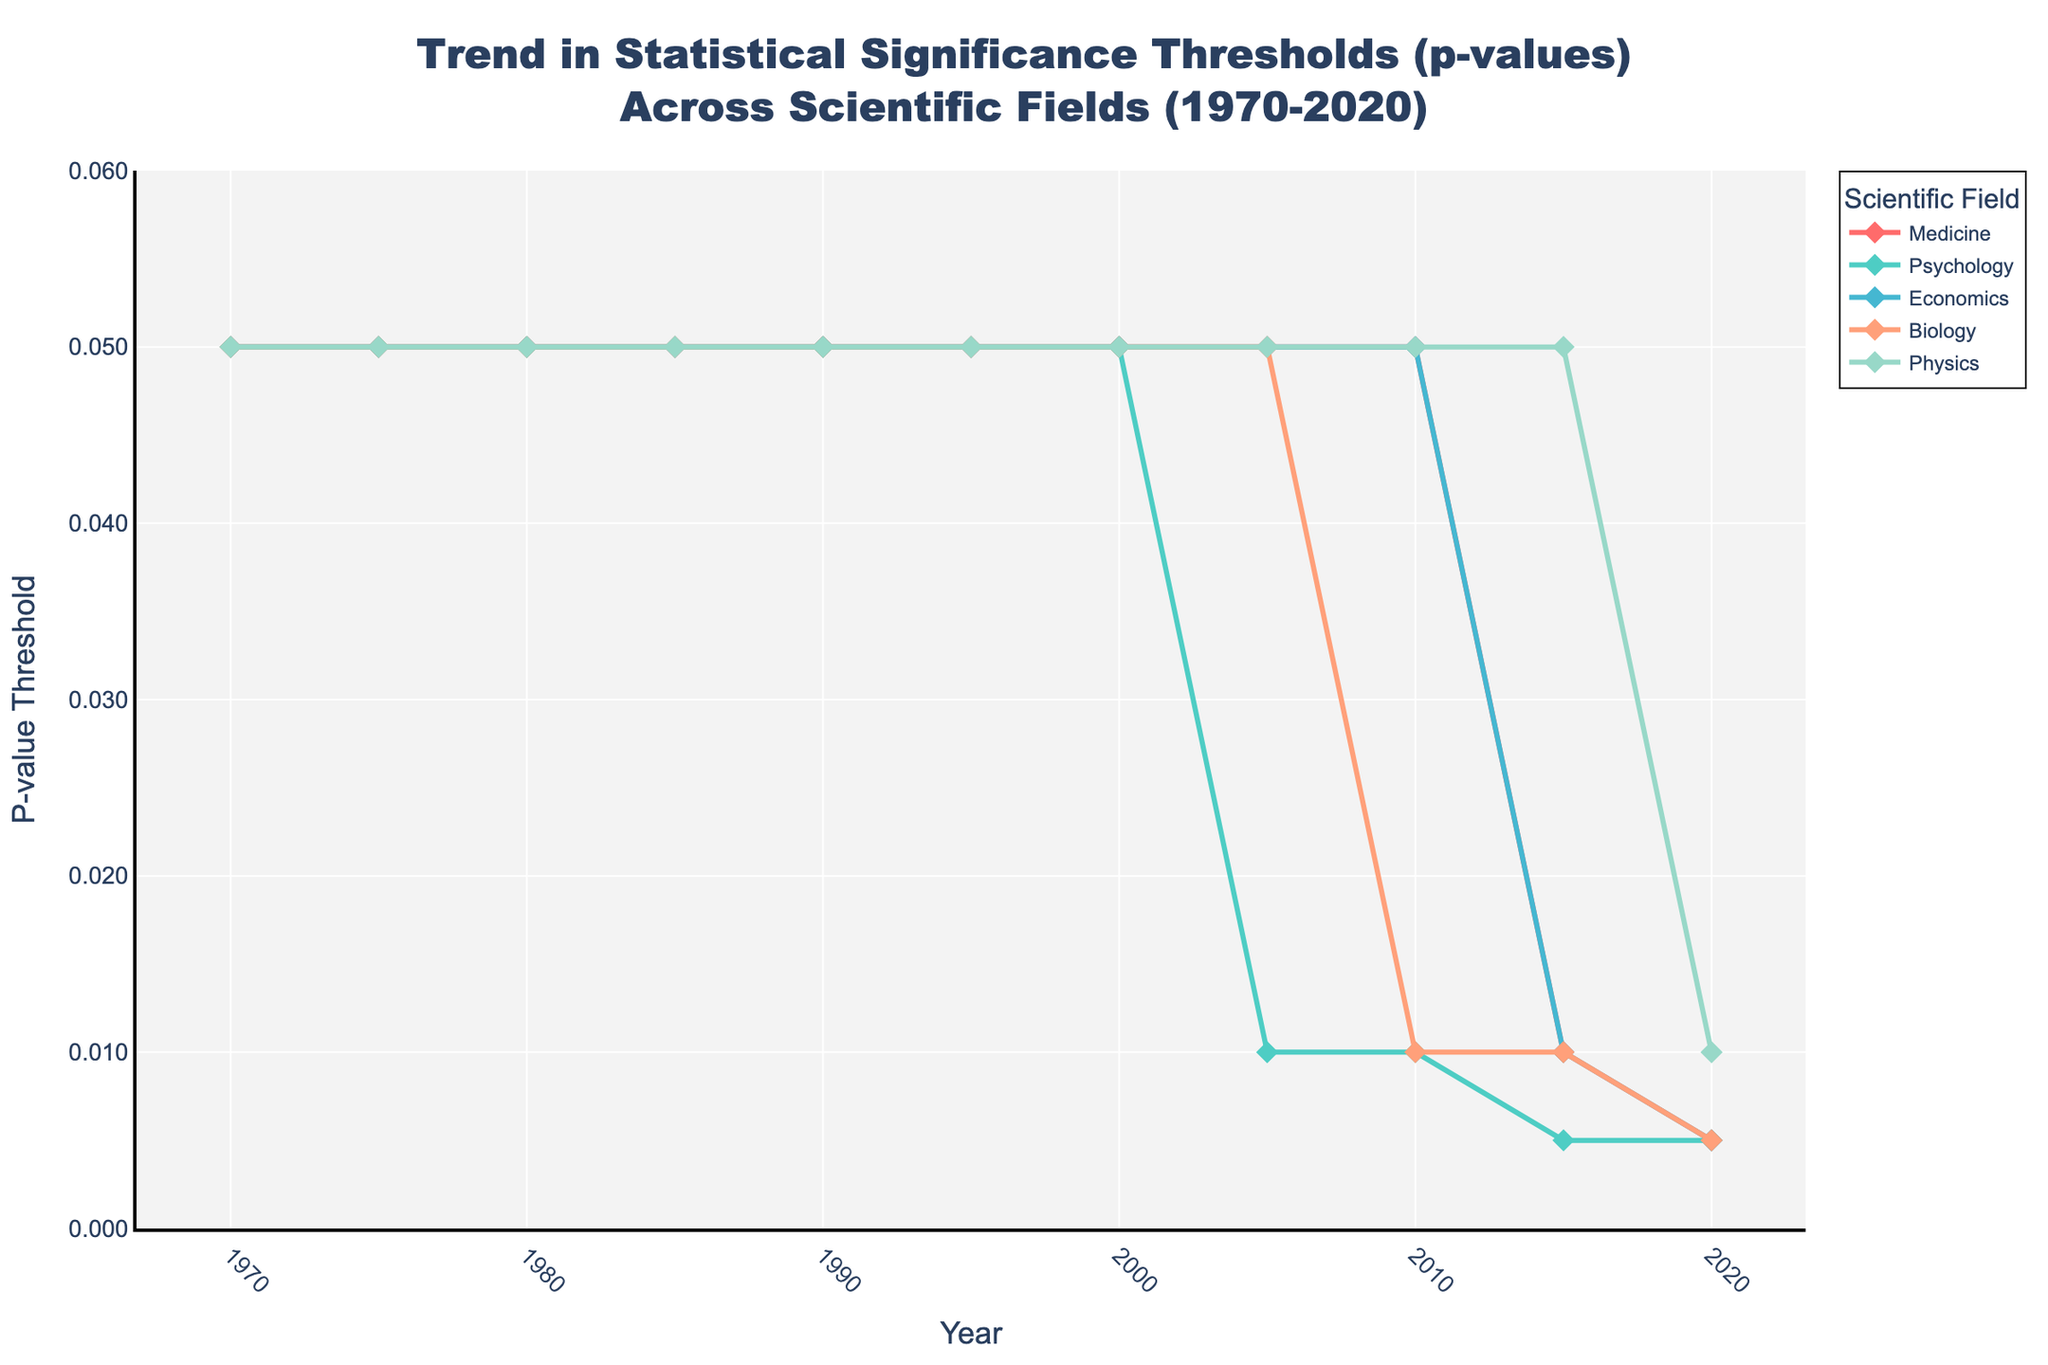What trend can be observed in the p-value thresholds for the field of Medicine from 1970 to 2020? The p-value thresholds in Medicine remained constant at 0.05 until 2015, after which there was a decrease to 0.01 in 2015 and further to 0.005 in 2020.
Answer: Decreasing trend Which scientific field shows the most significant reduction in p-value thresholds over the 50-year period? By observing the changes in the figure, Psychology experienced the largest reduction, moving from 0.05 to 0.005 over 50 years.
Answer: Psychology Between 2005 and 2010, which field exhibited the first notable drop in p-value thresholds and by how much? Psychology shows a reduction from 0.05 to 0.01. Subtracting these values gives 0.05 - 0.01 = 0.04.
Answer: Psychology, 0.04 Comparing the year 2020, which field has the highest p-value threshold and what is its value? Visual inspection shows that Physics has the highest p-value threshold in 2020 with a value of 0.01.
Answer: Physics, 0.01 From 1970 to 2020, how many scientific fields reduced their p-value thresholds below 0.05? By examining the final points in the figure, Medicine, Psychology, Economics, and Biology all reduced their thresholds below 0.05. Thus the count is 4.
Answer: 4 In 2010, which field has the smallest p-value threshold and what is the threshold value? The figure indicates that Psychology has the smallest threshold, which is 0.01.
Answer: Psychology, 0.01 Calculate the average p-value threshold across all fields for the years when they were at their lowest values. The fields have the lowest values in 2020: 0.005 (Medicine), 0.005 (Psychology), 0.005 (Economics), 0.005 (Biology), 0.01 (Physics). The average is (0.005 + 0.005 + 0.005 + 0.005 + 0.01) / 5 = 0.006.
Answer: 0.006 Comparing the initial and final years (1970 and 2020), which field shows the smallest relative change in p-value threshold? Physics remained constant until 2015 and only reduced to 0.01 in 2020, resulting in the smallest relative change from 0.05 to 0.01.
Answer: Physics 